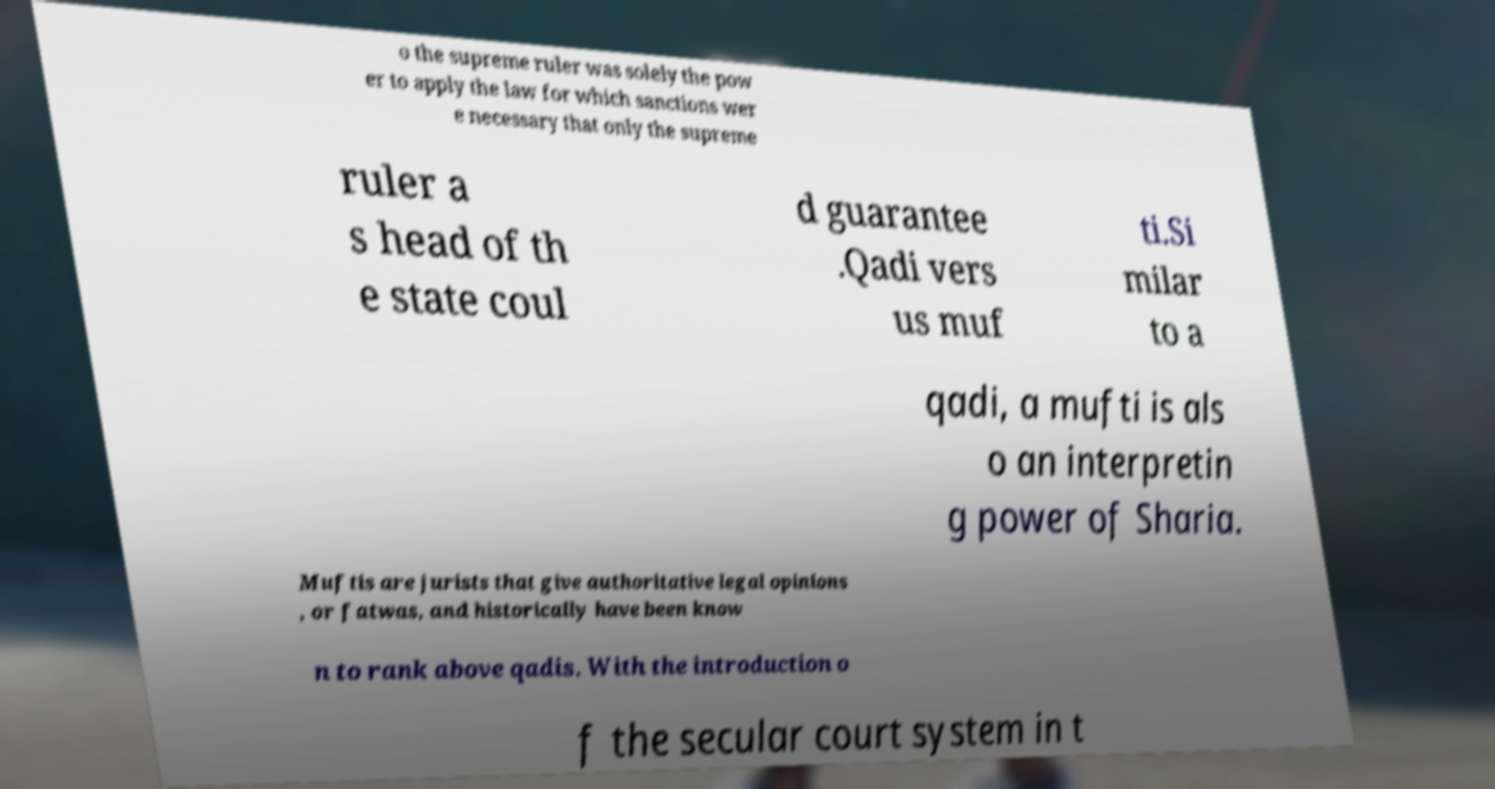Could you extract and type out the text from this image? o the supreme ruler was solely the pow er to apply the law for which sanctions wer e necessary that only the supreme ruler a s head of th e state coul d guarantee .Qadi vers us muf ti.Si milar to a qadi, a mufti is als o an interpretin g power of Sharia. Muftis are jurists that give authoritative legal opinions , or fatwas, and historically have been know n to rank above qadis. With the introduction o f the secular court system in t 